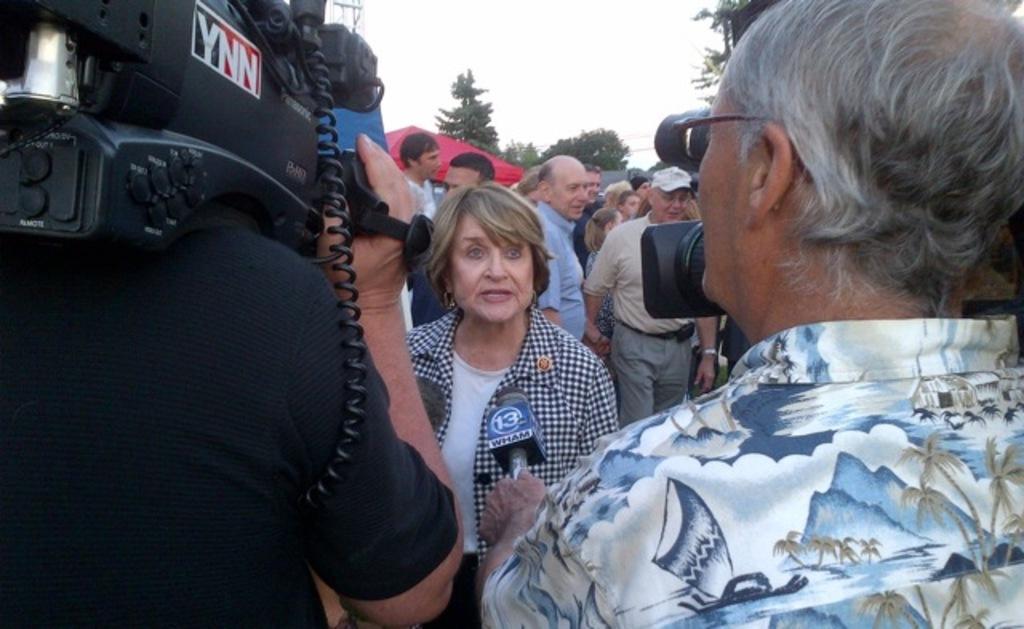Can you describe this image briefly? In the image I can see a person who is holding the camera and the other person is holding the mic and also I can see some other people some trees. 